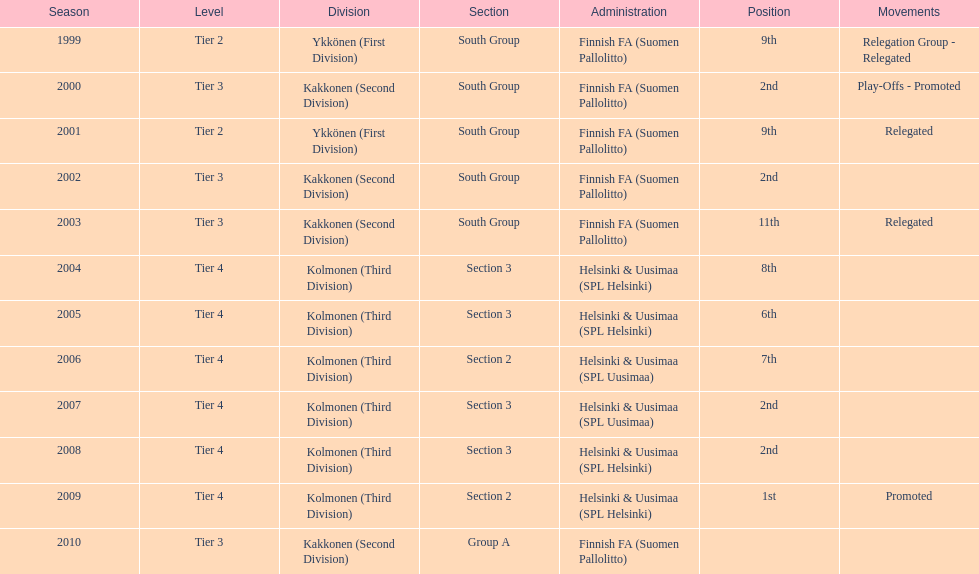What was the latest year they secured the 2nd position? 2008. Can you give me this table as a dict? {'header': ['Season', 'Level', 'Division', 'Section', 'Administration', 'Position', 'Movements'], 'rows': [['1999', 'Tier 2', 'Ykkönen (First Division)', 'South Group', 'Finnish FA (Suomen Pallolitto)', '9th', 'Relegation Group - Relegated'], ['2000', 'Tier 3', 'Kakkonen (Second Division)', 'South Group', 'Finnish FA (Suomen Pallolitto)', '2nd', 'Play-Offs - Promoted'], ['2001', 'Tier 2', 'Ykkönen (First Division)', 'South Group', 'Finnish FA (Suomen Pallolitto)', '9th', 'Relegated'], ['2002', 'Tier 3', 'Kakkonen (Second Division)', 'South Group', 'Finnish FA (Suomen Pallolitto)', '2nd', ''], ['2003', 'Tier 3', 'Kakkonen (Second Division)', 'South Group', 'Finnish FA (Suomen Pallolitto)', '11th', 'Relegated'], ['2004', 'Tier 4', 'Kolmonen (Third Division)', 'Section 3', 'Helsinki & Uusimaa (SPL Helsinki)', '8th', ''], ['2005', 'Tier 4', 'Kolmonen (Third Division)', 'Section 3', 'Helsinki & Uusimaa (SPL Helsinki)', '6th', ''], ['2006', 'Tier 4', 'Kolmonen (Third Division)', 'Section 2', 'Helsinki & Uusimaa (SPL Uusimaa)', '7th', ''], ['2007', 'Tier 4', 'Kolmonen (Third Division)', 'Section 3', 'Helsinki & Uusimaa (SPL Uusimaa)', '2nd', ''], ['2008', 'Tier 4', 'Kolmonen (Third Division)', 'Section 3', 'Helsinki & Uusimaa (SPL Helsinki)', '2nd', ''], ['2009', 'Tier 4', 'Kolmonen (Third Division)', 'Section 2', 'Helsinki & Uusimaa (SPL Helsinki)', '1st', 'Promoted'], ['2010', 'Tier 3', 'Kakkonen (Second Division)', 'Group A', 'Finnish FA (Suomen Pallolitto)', '', '']]} 